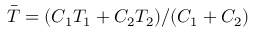Convert formula to latex. <formula><loc_0><loc_0><loc_500><loc_500>\bar { T } = ( C _ { 1 } T _ { 1 } + C _ { 2 } T _ { 2 } ) / ( C _ { 1 } + C _ { 2 } )</formula> 